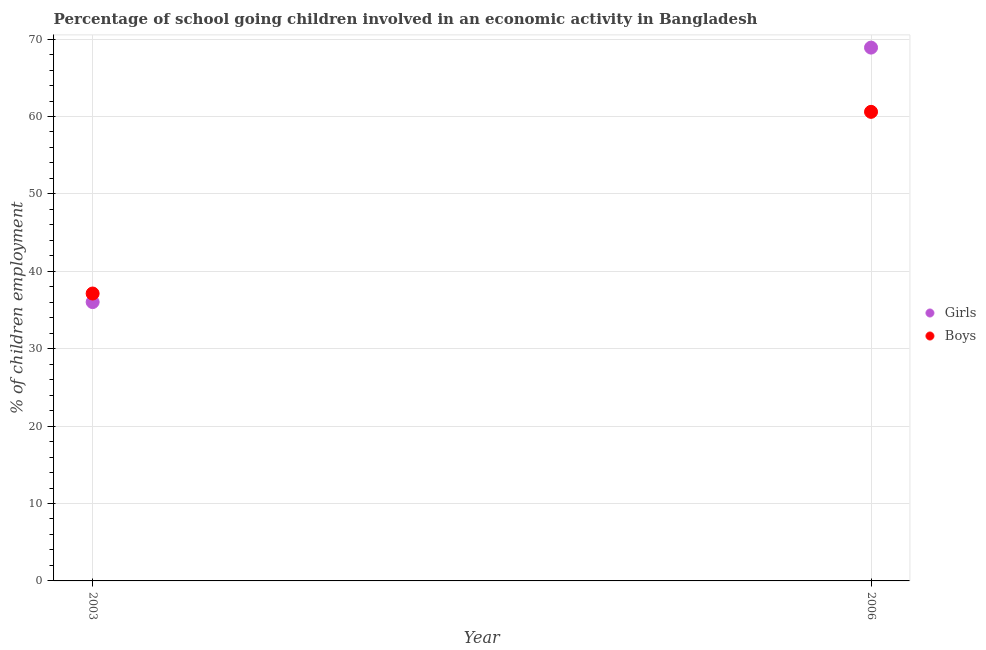How many different coloured dotlines are there?
Your response must be concise. 2. What is the percentage of school going boys in 2006?
Offer a very short reply. 60.6. Across all years, what is the maximum percentage of school going girls?
Your answer should be very brief. 68.9. Across all years, what is the minimum percentage of school going girls?
Provide a succinct answer. 36.02. In which year was the percentage of school going boys maximum?
Make the answer very short. 2006. What is the total percentage of school going boys in the graph?
Provide a short and direct response. 97.73. What is the difference between the percentage of school going girls in 2003 and that in 2006?
Give a very brief answer. -32.88. What is the difference between the percentage of school going girls in 2003 and the percentage of school going boys in 2006?
Ensure brevity in your answer.  -24.58. What is the average percentage of school going girls per year?
Your answer should be very brief. 52.46. In the year 2003, what is the difference between the percentage of school going girls and percentage of school going boys?
Your response must be concise. -1.11. What is the ratio of the percentage of school going girls in 2003 to that in 2006?
Make the answer very short. 0.52. Does the percentage of school going boys monotonically increase over the years?
Provide a short and direct response. Yes. Is the percentage of school going boys strictly greater than the percentage of school going girls over the years?
Give a very brief answer. No. Is the percentage of school going girls strictly less than the percentage of school going boys over the years?
Your response must be concise. No. How many dotlines are there?
Keep it short and to the point. 2. What is the difference between two consecutive major ticks on the Y-axis?
Offer a very short reply. 10. How many legend labels are there?
Offer a very short reply. 2. What is the title of the graph?
Offer a very short reply. Percentage of school going children involved in an economic activity in Bangladesh. Does "International Tourists" appear as one of the legend labels in the graph?
Ensure brevity in your answer.  No. What is the label or title of the X-axis?
Offer a terse response. Year. What is the label or title of the Y-axis?
Provide a short and direct response. % of children employment. What is the % of children employment of Girls in 2003?
Give a very brief answer. 36.02. What is the % of children employment of Boys in 2003?
Offer a very short reply. 37.13. What is the % of children employment of Girls in 2006?
Provide a succinct answer. 68.9. What is the % of children employment of Boys in 2006?
Keep it short and to the point. 60.6. Across all years, what is the maximum % of children employment of Girls?
Give a very brief answer. 68.9. Across all years, what is the maximum % of children employment of Boys?
Your answer should be compact. 60.6. Across all years, what is the minimum % of children employment of Girls?
Keep it short and to the point. 36.02. Across all years, what is the minimum % of children employment of Boys?
Make the answer very short. 37.13. What is the total % of children employment in Girls in the graph?
Provide a short and direct response. 104.92. What is the total % of children employment of Boys in the graph?
Make the answer very short. 97.73. What is the difference between the % of children employment of Girls in 2003 and that in 2006?
Give a very brief answer. -32.88. What is the difference between the % of children employment in Boys in 2003 and that in 2006?
Offer a terse response. -23.47. What is the difference between the % of children employment of Girls in 2003 and the % of children employment of Boys in 2006?
Your response must be concise. -24.58. What is the average % of children employment in Girls per year?
Your answer should be very brief. 52.46. What is the average % of children employment in Boys per year?
Provide a succinct answer. 48.86. In the year 2003, what is the difference between the % of children employment in Girls and % of children employment in Boys?
Provide a succinct answer. -1.11. In the year 2006, what is the difference between the % of children employment in Girls and % of children employment in Boys?
Make the answer very short. 8.3. What is the ratio of the % of children employment of Girls in 2003 to that in 2006?
Offer a very short reply. 0.52. What is the ratio of the % of children employment in Boys in 2003 to that in 2006?
Provide a succinct answer. 0.61. What is the difference between the highest and the second highest % of children employment of Girls?
Keep it short and to the point. 32.88. What is the difference between the highest and the second highest % of children employment of Boys?
Your answer should be very brief. 23.47. What is the difference between the highest and the lowest % of children employment of Girls?
Make the answer very short. 32.88. What is the difference between the highest and the lowest % of children employment in Boys?
Provide a short and direct response. 23.47. 